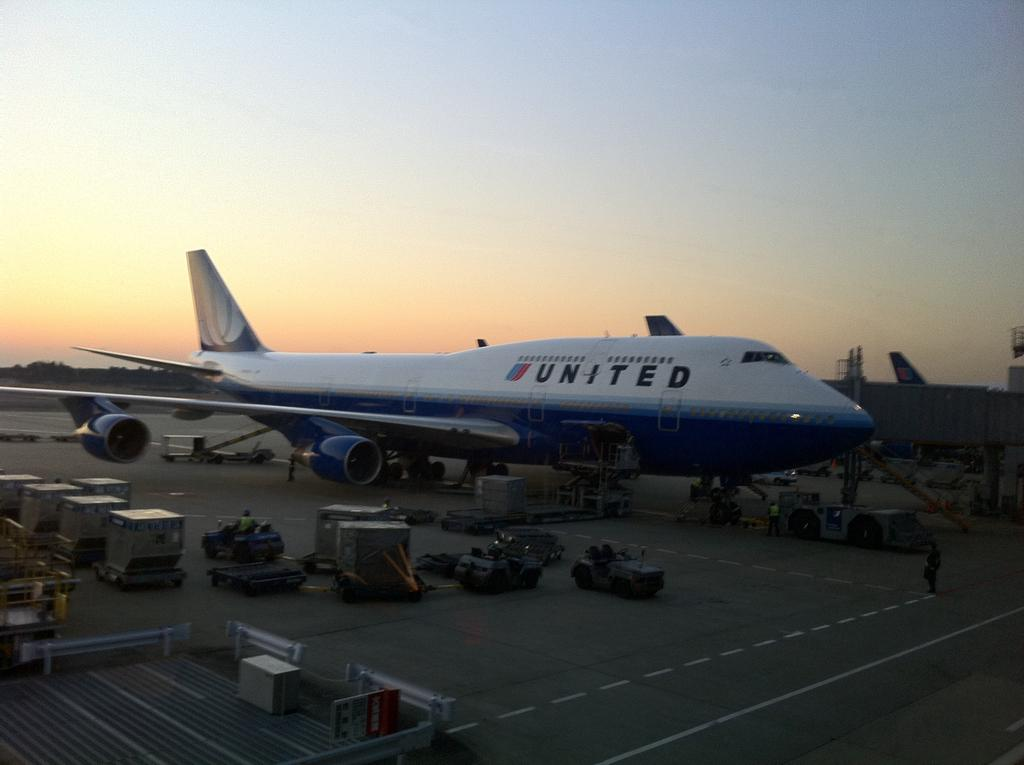<image>
Render a clear and concise summary of the photo. A United passenger jet is being loaded with baggages on the tarmac. 